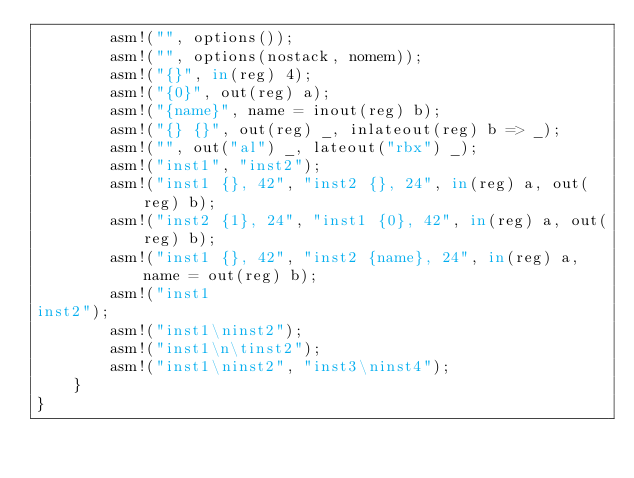Convert code to text. <code><loc_0><loc_0><loc_500><loc_500><_Rust_>        asm!("", options());
        asm!("", options(nostack, nomem));
        asm!("{}", in(reg) 4);
        asm!("{0}", out(reg) a);
        asm!("{name}", name = inout(reg) b);
        asm!("{} {}", out(reg) _, inlateout(reg) b => _);
        asm!("", out("al") _, lateout("rbx") _);
        asm!("inst1", "inst2");
        asm!("inst1 {}, 42", "inst2 {}, 24", in(reg) a, out(reg) b);
        asm!("inst2 {1}, 24", "inst1 {0}, 42", in(reg) a, out(reg) b);
        asm!("inst1 {}, 42", "inst2 {name}, 24", in(reg) a, name = out(reg) b);
        asm!("inst1
inst2");
        asm!("inst1\ninst2");
        asm!("inst1\n\tinst2");
        asm!("inst1\ninst2", "inst3\ninst4");
    }
}
</code> 